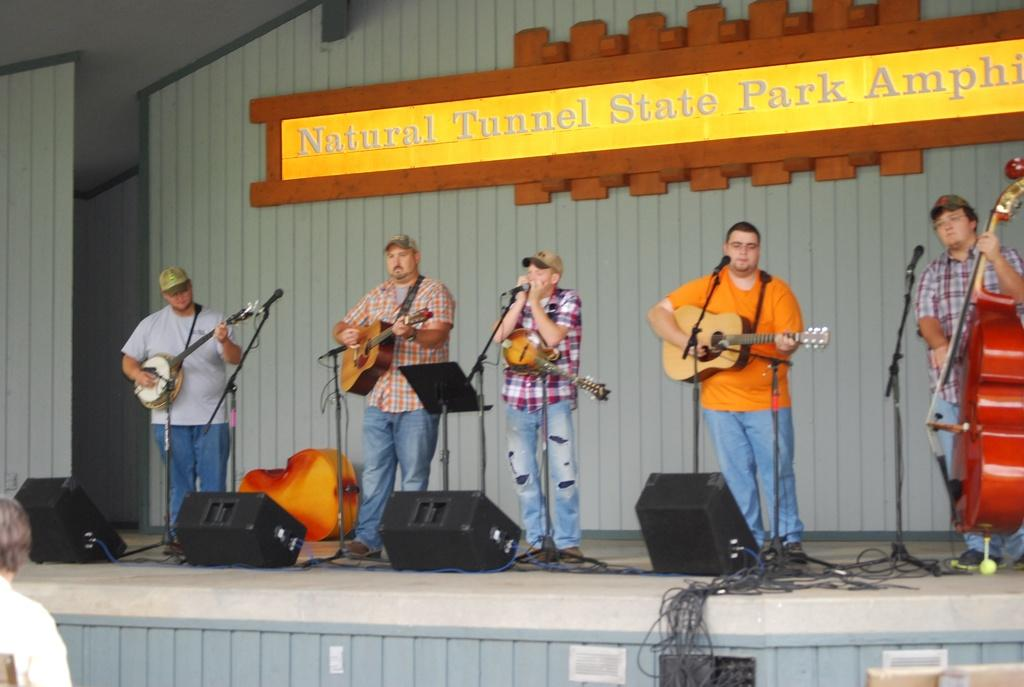What is the main subject of the image? The main subject of the image is a group of men. Where are the men located in the image? The men are standing on a stage in the image. What are the men doing on the stage? The men are playing guitars in the image. What can be seen hanging above the stage? There is a banner displayed in the image. What is present at the bottom of the stage? There is a light box at the bottom of the stage in the image. How many snails can be seen crawling on the stage in the image? There are no snails present in the image; the men are playing guitars on the stage. 